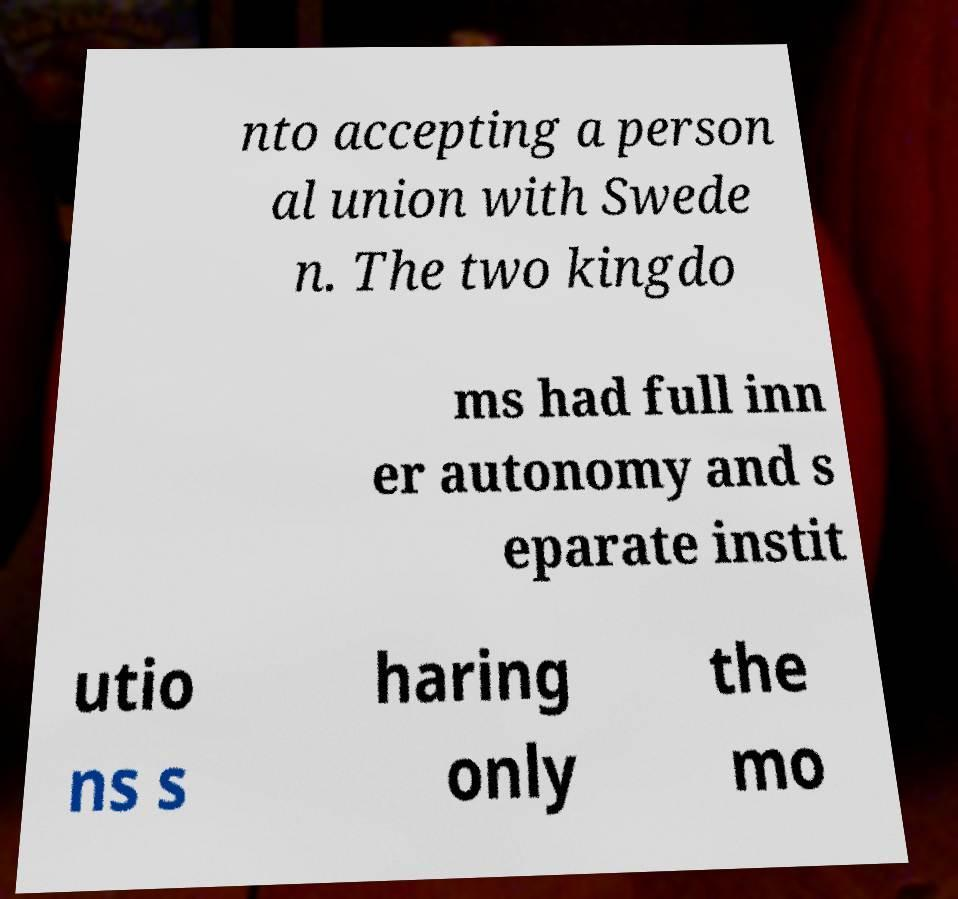Can you read and provide the text displayed in the image?This photo seems to have some interesting text. Can you extract and type it out for me? nto accepting a person al union with Swede n. The two kingdo ms had full inn er autonomy and s eparate instit utio ns s haring only the mo 